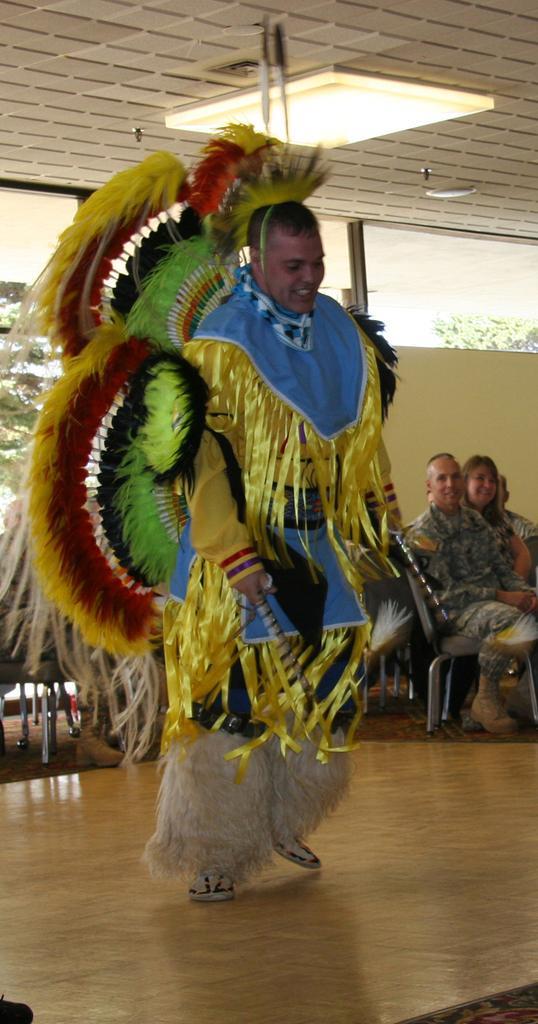In one or two sentences, can you explain what this image depicts? In the middle of the picture, we see a man in yellow dress is dancing on the stage. Beside him, we see people sitting on the chairs and watching the man who is dancing. At the top of the picture, we see the ceiling of the room. Behind him, we see a window from which we can see trees. 